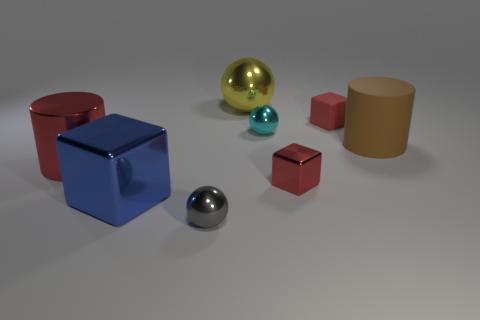There is a shiny object that is both in front of the large brown matte thing and right of the big yellow metal object; what is its color? The shiny object located in front of the large brown matte cube and to the right of the big yellow metallic sphere is predominantly blue with a chrome-like reflective surface. It appears to be a smaller version of the two larger objects with a clearly visible reflection and a glossy texture. 